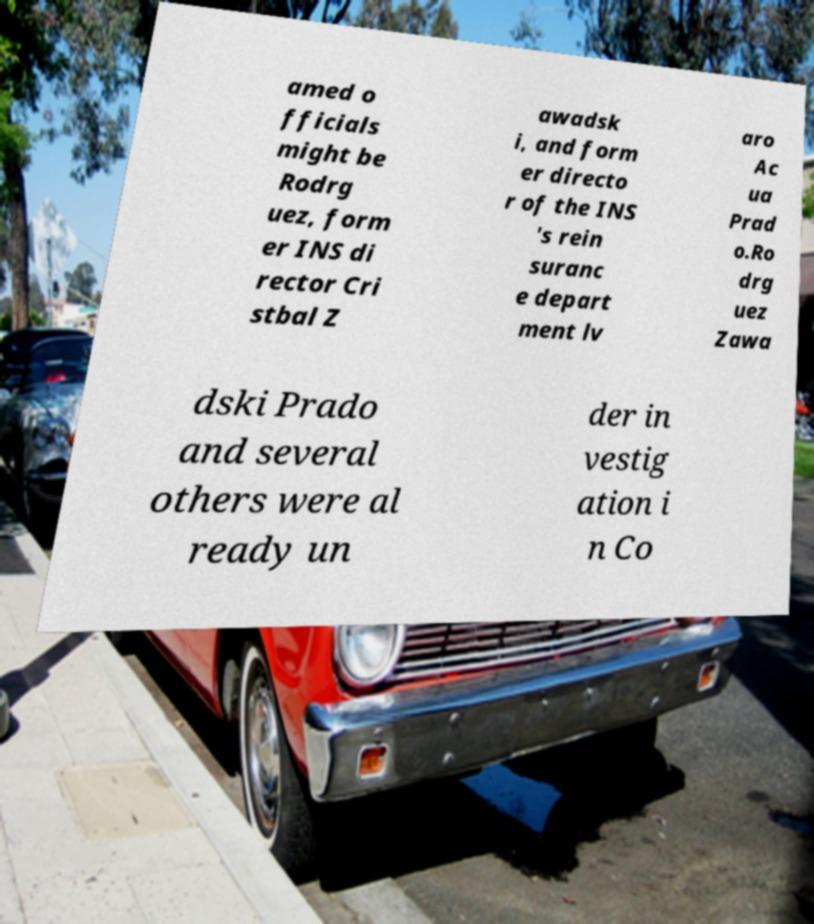What messages or text are displayed in this image? I need them in a readable, typed format. amed o fficials might be Rodrg uez, form er INS di rector Cri stbal Z awadsk i, and form er directo r of the INS 's rein suranc e depart ment lv aro Ac ua Prad o.Ro drg uez Zawa dski Prado and several others were al ready un der in vestig ation i n Co 